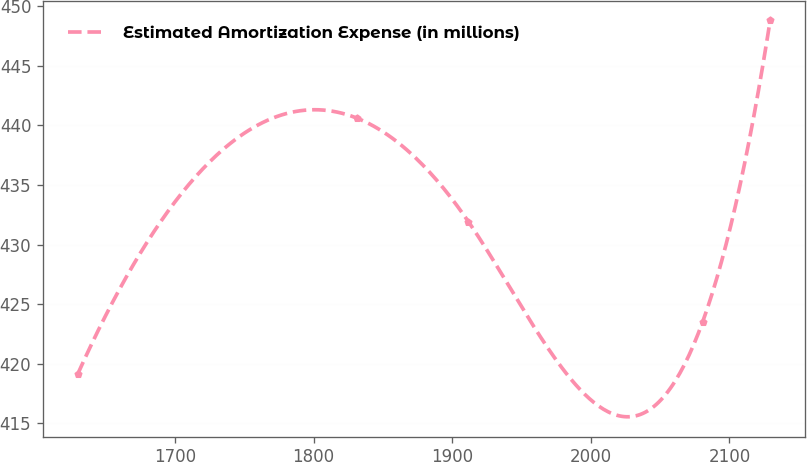<chart> <loc_0><loc_0><loc_500><loc_500><line_chart><ecel><fcel>Estimated Amortization Expense (in millions)<nl><fcel>1629.67<fcel>419.11<nl><fcel>1831.32<fcel>440.6<nl><fcel>1911.62<fcel>431.93<nl><fcel>2080.71<fcel>423.52<nl><fcel>2129.41<fcel>448.8<nl></chart> 